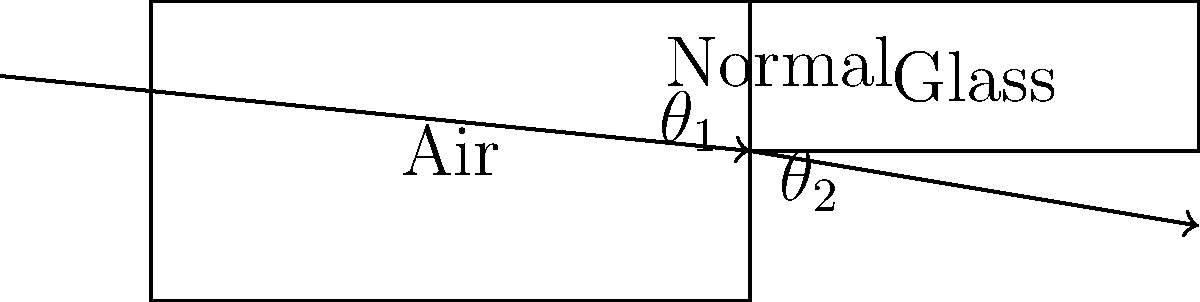In the context of light refraction, how might the societal perception of scientific phenomena influence voter behavior regarding policies on renewable energy technologies like solar power? Consider the ray diagram showing light passing from air into glass, and explain how understanding this concept could impact public opinion on solar energy initiatives. To answer this question, let's break it down into steps that connect the physics concept with societal implications:

1. Understanding the physics:
   - The diagram shows light refracting as it passes from air into glass.
   - The angle of incidence ($\theta_1$) in air is greater than the angle of refraction ($\theta_2$) in glass.
   - This is described by Snell's Law: $n_1 \sin(\theta_1) = n_2 \sin(\theta_2)$, where $n$ is the refractive index.

2. Relevance to solar power:
   - Solar panels rely on the refraction and reflection of light to capture and convert solar energy.
   - Understanding refraction is crucial for designing efficient solar panels and determining optimal placement.

3. Societal perception:
   - Public understanding of scientific concepts like refraction can influence perceptions of renewable energy technologies.
   - A society with a strong grasp of basic physics may be more likely to support solar energy initiatives.

4. Voter behavior:
   - Voters who understand the science behind solar power may be more inclined to support policies promoting its development and implementation.
   - Conversely, lack of understanding may lead to skepticism or resistance to such policies.

5. Societal factors:
   - Education systems, media coverage, and cultural attitudes towards science all play a role in shaping public understanding of physics concepts.
   - These societal factors can have a more significant impact on voter behavior than media influence alone.

6. Policy implications:
   - Policymakers may need to consider public scientific literacy when crafting and promoting renewable energy policies.
   - Educational initiatives explaining the physics behind solar power could potentially influence voter support for related policies.

In conclusion, while the physics of light refraction is fundamental to solar power technology, societal factors such as education, cultural attitudes, and overall scientific literacy play a crucial role in shaping voter behavior regarding renewable energy policies. Understanding these societal dynamics is essential for predicting and influencing public support for solar energy initiatives.
Answer: Societal factors, including scientific literacy and cultural attitudes, significantly influence voter support for solar energy policies, outweighing direct media influence. 